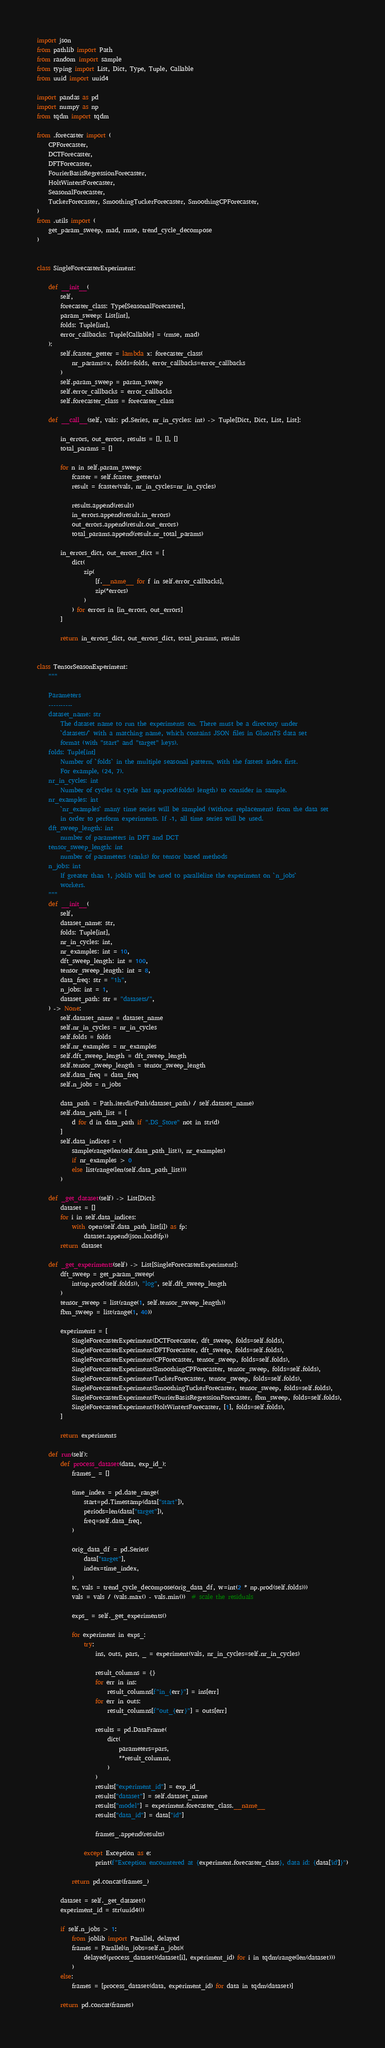Convert code to text. <code><loc_0><loc_0><loc_500><loc_500><_Python_>import json
from pathlib import Path
from random import sample
from typing import List, Dict, Type, Tuple, Callable
from uuid import uuid4

import pandas as pd
import numpy as np
from tqdm import tqdm

from .forecaster import (
    CPForecaster,
    DCTForecaster,
    DFTForecaster,
    FourierBasisRegressionForecaster,
    HoltWintersForecaster,
    SeasonalForecaster,
    TuckerForecaster, SmoothingTuckerForecaster, SmoothingCPForecaster,
)
from .utils import (
    get_param_sweep, mad, rmse, trend_cycle_decompose
)


class SingleForecasterExperiment:

    def __init__(
        self,
        forecaster_class: Type[SeasonalForecaster],
        param_sweep: List[int],
        folds: Tuple[int],
        error_callbacks: Tuple[Callable] = (rmse, mad)
    ):
        self.fcaster_getter = lambda x: forecaster_class(
            nr_params=x, folds=folds, error_callbacks=error_callbacks
        )
        self.param_sweep = param_sweep
        self.error_callbacks = error_callbacks
        self.forecaster_class = forecaster_class

    def __call__(self, vals: pd.Series, nr_in_cycles: int) -> Tuple[Dict, Dict, List, List]:

        in_errors, out_errors, results = [], [], []
        total_params = []

        for n in self.param_sweep:
            fcaster = self.fcaster_getter(n)
            result = fcaster(vals, nr_in_cycles=nr_in_cycles)

            results.append(result)
            in_errors.append(result.in_errors)
            out_errors.append(result.out_errors)
            total_params.append(result.nr_total_params)

        in_errors_dict, out_errors_dict = [
            dict(
                zip(
                    [f.__name__ for f in self.error_callbacks],
                    zip(*errors)
                )
            ) for errors in [in_errors, out_errors]
        ]

        return in_errors_dict, out_errors_dict, total_params, results


class TensorSeasonExperiment:
    """

    Parameters
    ----------
    dataset_name: str
        The dataset name to run the experiments on. There must be a directory under
        `datasets/` with a matching name, which contains JSON files in GluonTS data set
        format (with "start" and "target" keys).
    folds: Tuple[int]
        Number of `folds` in the multiple seasonal pattern, with the fastest index first.
        For example, (24, 7).
    nr_in_cycles: int
        Number of cycles (a cycle has np.prod(folds) length) to consider in sample.
    nr_examples: int
        `nr_examples` many time series will be sampled (without replacement) from the data set
        in order to perform experiments. If -1, all time series will be used.
    dft_sweep_length: int
        number of parameters in DFT and DCT
    tensor_sweep_length: int
        number of parameters (ranks) for tensor based methods
    n_jobs: int
        If greater than 1, joblib will be used to parallelize the experiment on `n_jobs`
        workers.
    """
    def __init__(
        self,
        dataset_name: str,
        folds: Tuple[int],
        nr_in_cycles: int,
        nr_examples: int = 10,
        dft_sweep_length: int = 100,
        tensor_sweep_length: int = 8,
        data_freq: str = "1h",
        n_jobs: int = 1,
        dataset_path: str = "datasets/",
    ) -> None:
        self.dataset_name = dataset_name
        self.nr_in_cycles = nr_in_cycles
        self.folds = folds
        self.nr_examples = nr_examples
        self.dft_sweep_length = dft_sweep_length
        self.tensor_sweep_length = tensor_sweep_length
        self.data_freq = data_freq
        self.n_jobs = n_jobs

        data_path = Path.iterdir(Path(dataset_path) / self.dataset_name)
        self.data_path_list = [
            d for d in data_path if ".DS_Store" not in str(d)
        ]
        self.data_indices = (
            sample(range(len(self.data_path_list)), nr_examples)
            if nr_examples > 0
            else list(range(len(self.data_path_list)))
        )

    def _get_dataset(self) -> List[Dict]:
        dataset = []
        for i in self.data_indices:
            with open(self.data_path_list[i]) as fp:
                dataset.append(json.load(fp))
        return dataset

    def _get_experiments(self) -> List[SingleForecasterExperiment]:
        dft_sweep = get_param_sweep(
            int(np.prod(self.folds)), "log", self.dft_sweep_length
        )
        tensor_sweep = list(range(1, self.tensor_sweep_length))
        fbm_sweep = list(range(1, 40))

        experiments = [
            SingleForecasterExperiment(DCTForecaster, dft_sweep, folds=self.folds),
            SingleForecasterExperiment(DFTForecaster, dft_sweep, folds=self.folds),
            SingleForecasterExperiment(CPForecaster, tensor_sweep, folds=self.folds),
            SingleForecasterExperiment(SmoothingCPForecaster, tensor_sweep, folds=self.folds),
            SingleForecasterExperiment(TuckerForecaster, tensor_sweep, folds=self.folds),
            SingleForecasterExperiment(SmoothingTuckerForecaster, tensor_sweep, folds=self.folds),
            SingleForecasterExperiment(FourierBasisRegressionForecaster, fbm_sweep, folds=self.folds),
            SingleForecasterExperiment(HoltWintersForecaster, [1], folds=self.folds),
        ]

        return experiments

    def run(self):
        def process_dataset(data, exp_id_):
            frames_ = []

            time_index = pd.date_range(
                start=pd.Timestamp(data["start"]),
                periods=len(data["target"]),
                freq=self.data_freq,
            )

            orig_data_df = pd.Series(
                data["target"],
                index=time_index,
            )
            tc, vals = trend_cycle_decompose(orig_data_df, w=int(2 * np.prod(self.folds)))
            vals = vals / (vals.max() - vals.min())  # scale the residuals

            exps_ = self._get_experiments()

            for experiment in exps_:
                try:
                    ins, outs, pars, _ = experiment(vals, nr_in_cycles=self.nr_in_cycles)

                    result_columns = {}
                    for err in ins:
                        result_columns[f"in_{err}"] = ins[err]
                    for err in outs:
                        result_columns[f"out_{err}"] = outs[err]

                    results = pd.DataFrame(
                        dict(
                            parameters=pars,
                            **result_columns,
                        )
                    )
                    results["experiment_id"] = exp_id_
                    results["dataset"] = self.dataset_name
                    results["model"] = experiment.forecaster_class.__name__
                    results["data_id"] = data["id"]

                    frames_.append(results)

                except Exception as e:
                    print(f"Exception encountered at {experiment.forecaster_class}, data id: {data['id']}")

            return pd.concat(frames_)

        dataset = self._get_dataset()
        experiment_id = str(uuid4())

        if self.n_jobs > 1:
            from joblib import Parallel, delayed
            frames = Parallel(n_jobs=self.n_jobs)(
                delayed(process_dataset)(dataset[i], experiment_id) for i in tqdm(range(len(dataset)))
            )
        else:
            frames = [process_dataset(data, experiment_id) for data in tqdm(dataset)]

        return pd.concat(frames)
</code> 